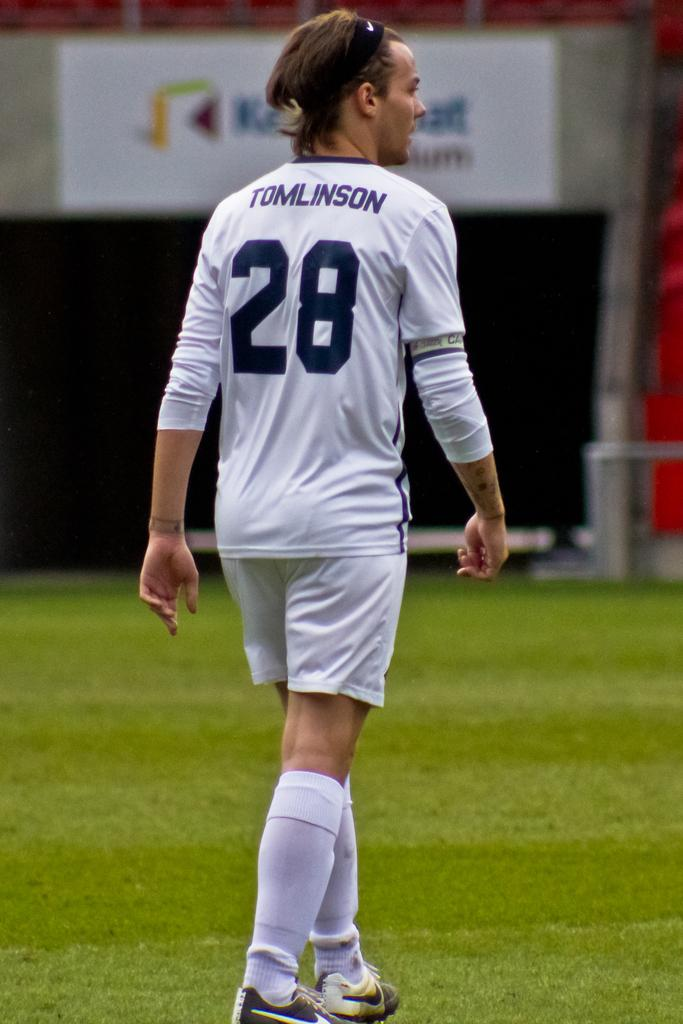<image>
Relay a brief, clear account of the picture shown. A soccer field with a woman wearing a shirt with the number 28 